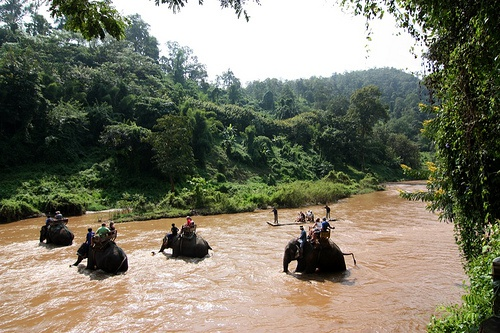Describe the objects in this image and their specific colors. I can see elephant in lightblue, black, and gray tones, elephant in lightblue, black, gray, and darkgray tones, elephant in lightblue, black, gray, and darkgray tones, elephant in lightblue, black, and gray tones, and people in lightblue, black, maroon, and gray tones in this image. 